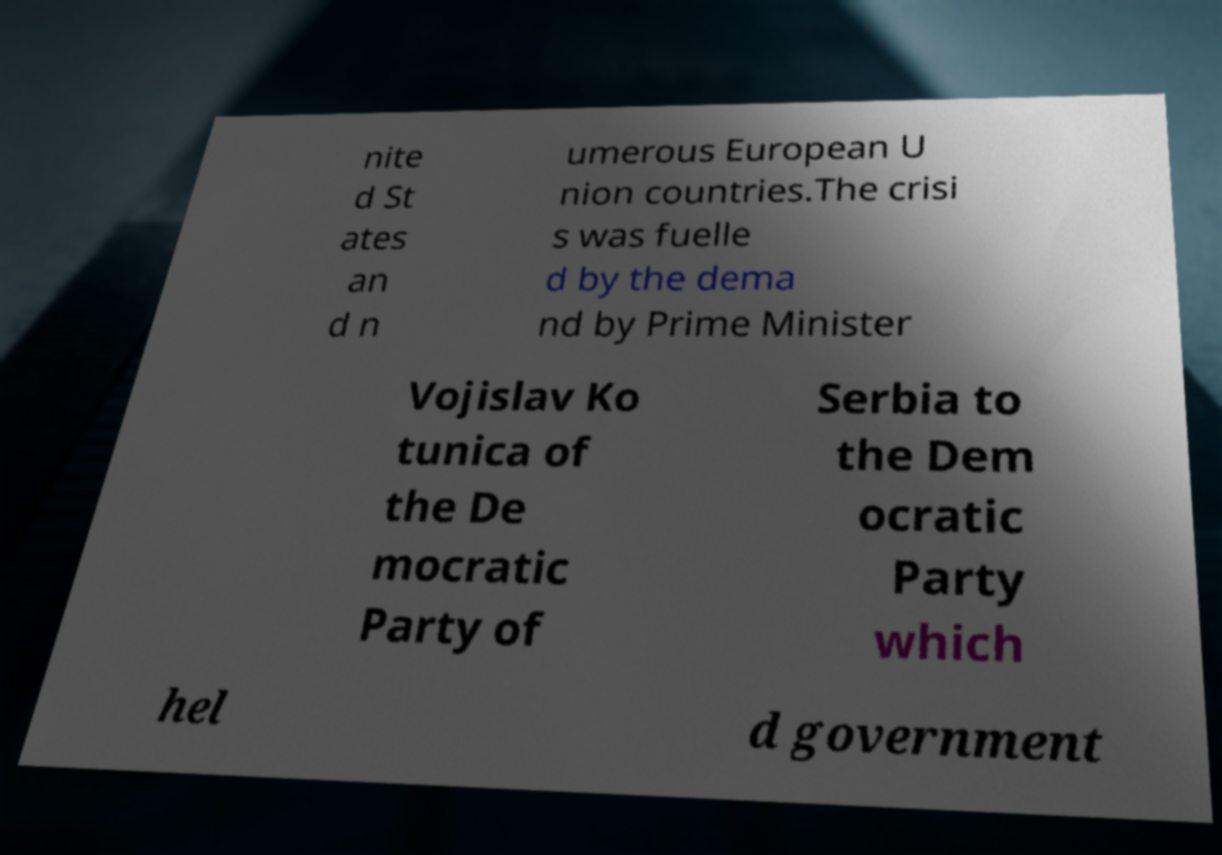What messages or text are displayed in this image? I need them in a readable, typed format. nite d St ates an d n umerous European U nion countries.The crisi s was fuelle d by the dema nd by Prime Minister Vojislav Ko tunica of the De mocratic Party of Serbia to the Dem ocratic Party which hel d government 